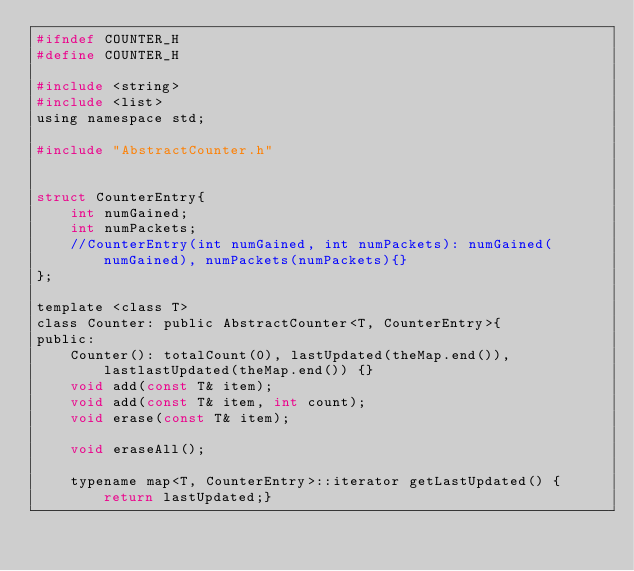<code> <loc_0><loc_0><loc_500><loc_500><_C_>#ifndef COUNTER_H
#define COUNTER_H

#include <string>
#include <list>
using namespace std;

#include "AbstractCounter.h"


struct CounterEntry{
	int numGained;
	int numPackets;	
	//CounterEntry(int numGained, int numPackets): numGained(numGained), numPackets(numPackets){}
};

template <class T>
class Counter: public AbstractCounter<T, CounterEntry>{
public:
	Counter(): totalCount(0), lastUpdated(theMap.end()), lastlastUpdated(theMap.end()) {}
	void add(const T& item);
	void add(const T& item, int count);
	void erase(const T& item);
	
	void eraseAll();

	typename map<T, CounterEntry>::iterator getLastUpdated() {return lastUpdated;}
	</code> 